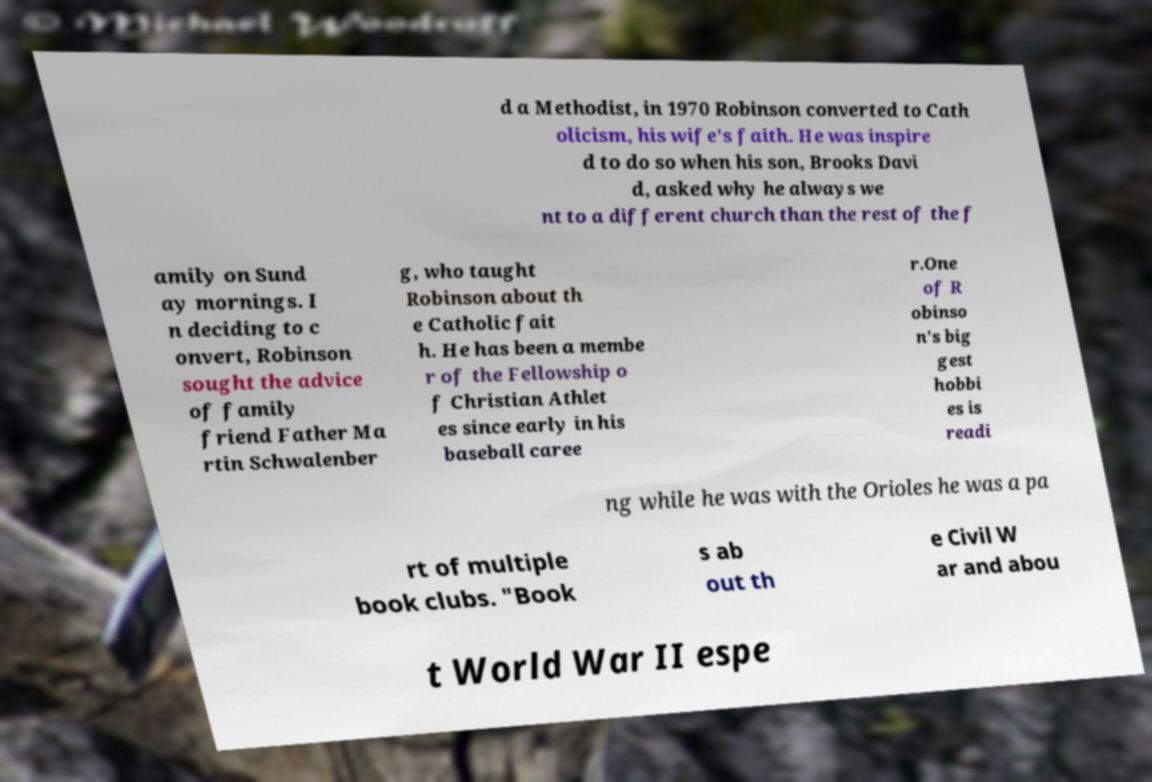Please read and relay the text visible in this image. What does it say? d a Methodist, in 1970 Robinson converted to Cath olicism, his wife's faith. He was inspire d to do so when his son, Brooks Davi d, asked why he always we nt to a different church than the rest of the f amily on Sund ay mornings. I n deciding to c onvert, Robinson sought the advice of family friend Father Ma rtin Schwalenber g, who taught Robinson about th e Catholic fait h. He has been a membe r of the Fellowship o f Christian Athlet es since early in his baseball caree r.One of R obinso n's big gest hobbi es is readi ng while he was with the Orioles he was a pa rt of multiple book clubs. "Book s ab out th e Civil W ar and abou t World War II espe 